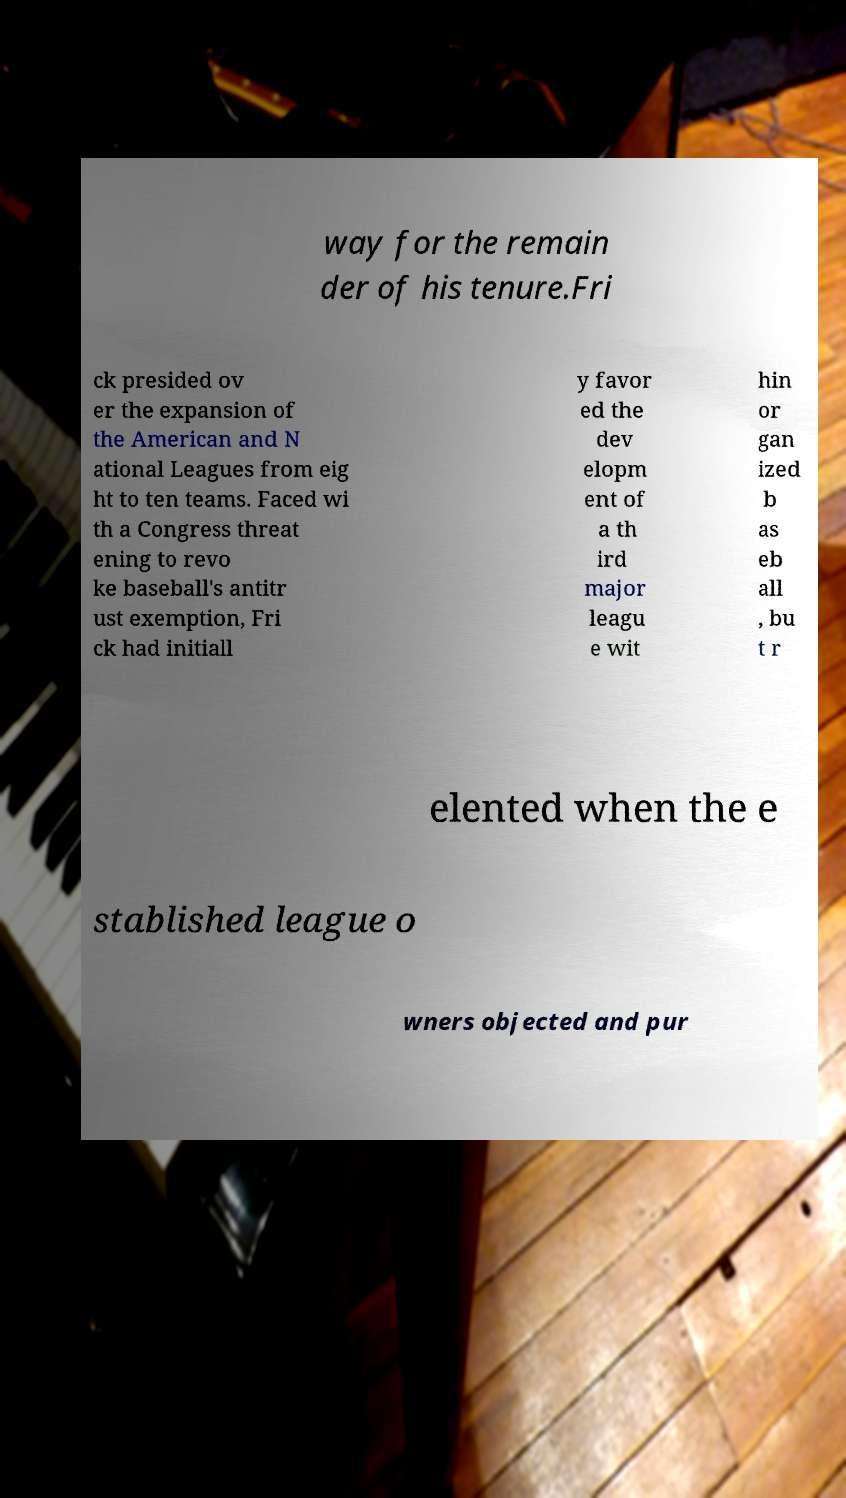I need the written content from this picture converted into text. Can you do that? way for the remain der of his tenure.Fri ck presided ov er the expansion of the American and N ational Leagues from eig ht to ten teams. Faced wi th a Congress threat ening to revo ke baseball's antitr ust exemption, Fri ck had initiall y favor ed the dev elopm ent of a th ird major leagu e wit hin or gan ized b as eb all , bu t r elented when the e stablished league o wners objected and pur 